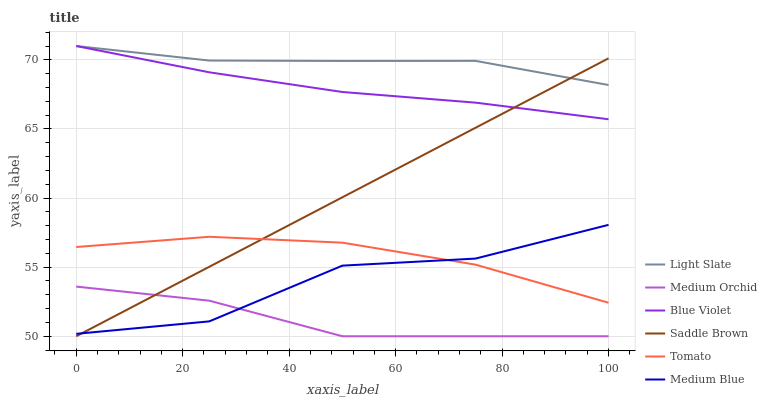Does Medium Orchid have the minimum area under the curve?
Answer yes or no. Yes. Does Light Slate have the maximum area under the curve?
Answer yes or no. Yes. Does Light Slate have the minimum area under the curve?
Answer yes or no. No. Does Medium Orchid have the maximum area under the curve?
Answer yes or no. No. Is Saddle Brown the smoothest?
Answer yes or no. Yes. Is Medium Blue the roughest?
Answer yes or no. Yes. Is Light Slate the smoothest?
Answer yes or no. No. Is Light Slate the roughest?
Answer yes or no. No. Does Light Slate have the lowest value?
Answer yes or no. No. Does Medium Orchid have the highest value?
Answer yes or no. No. Is Medium Orchid less than Blue Violet?
Answer yes or no. Yes. Is Light Slate greater than Medium Blue?
Answer yes or no. Yes. Does Medium Orchid intersect Blue Violet?
Answer yes or no. No. 